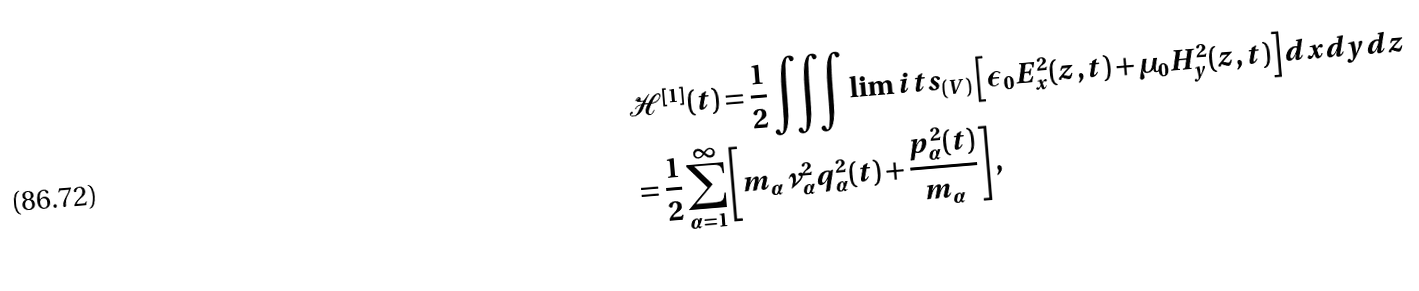<formula> <loc_0><loc_0><loc_500><loc_500>& \mathcal { H } ^ { [ 1 ] } ( t ) = \frac { 1 } { 2 } \iiint \lim i t s _ { ( V ) } \left [ \epsilon _ { 0 } E _ { x } ^ { 2 } ( z , t ) + \mu _ { 0 } H _ { y } ^ { 2 } ( z , t ) \right ] d x d y d z \\ & = \frac { 1 } { 2 } \sum _ { \alpha = 1 } ^ { \infty } \left [ m _ { \alpha } \nu _ { \alpha } ^ { 2 } q _ { \alpha } ^ { 2 } ( t ) + \frac { p _ { \alpha } ^ { 2 } ( t ) } { m _ { \alpha } } \right ] ,</formula> 